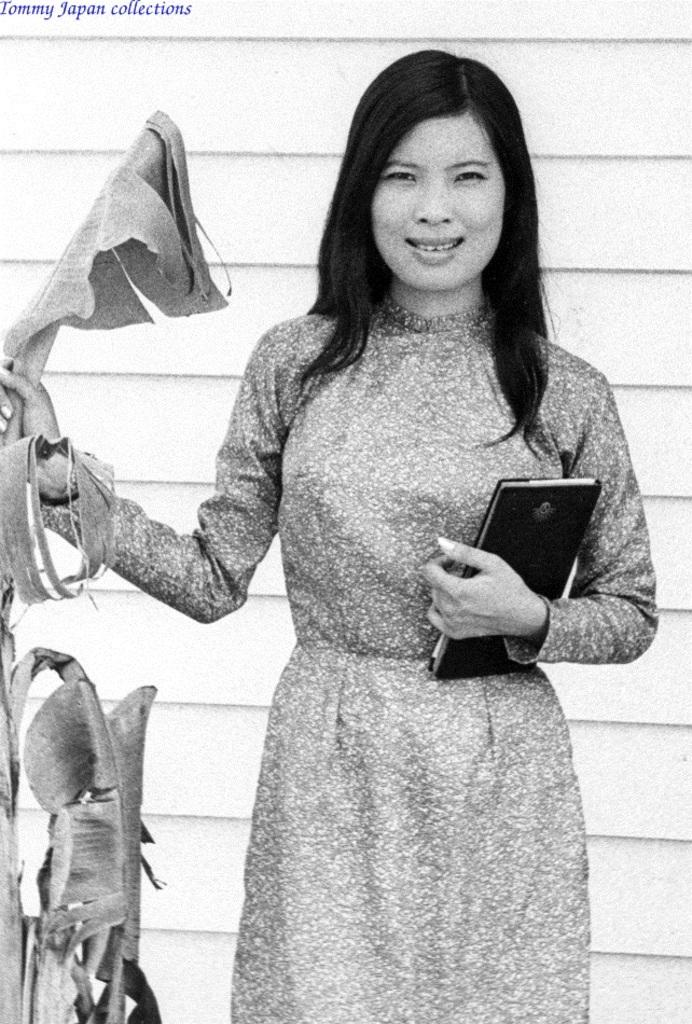Who is present in the image? There is a woman in the image. What is the woman holding? The woman is holding a book. What other object can be seen in the image? There is a plant in the image. What is the color of the wall in the background? There is a white wall in the background of the image. How many ladybugs are crawling on the plant in the image? There are no ladybugs present in the image; only the woman, the book, and the plant are visible. 